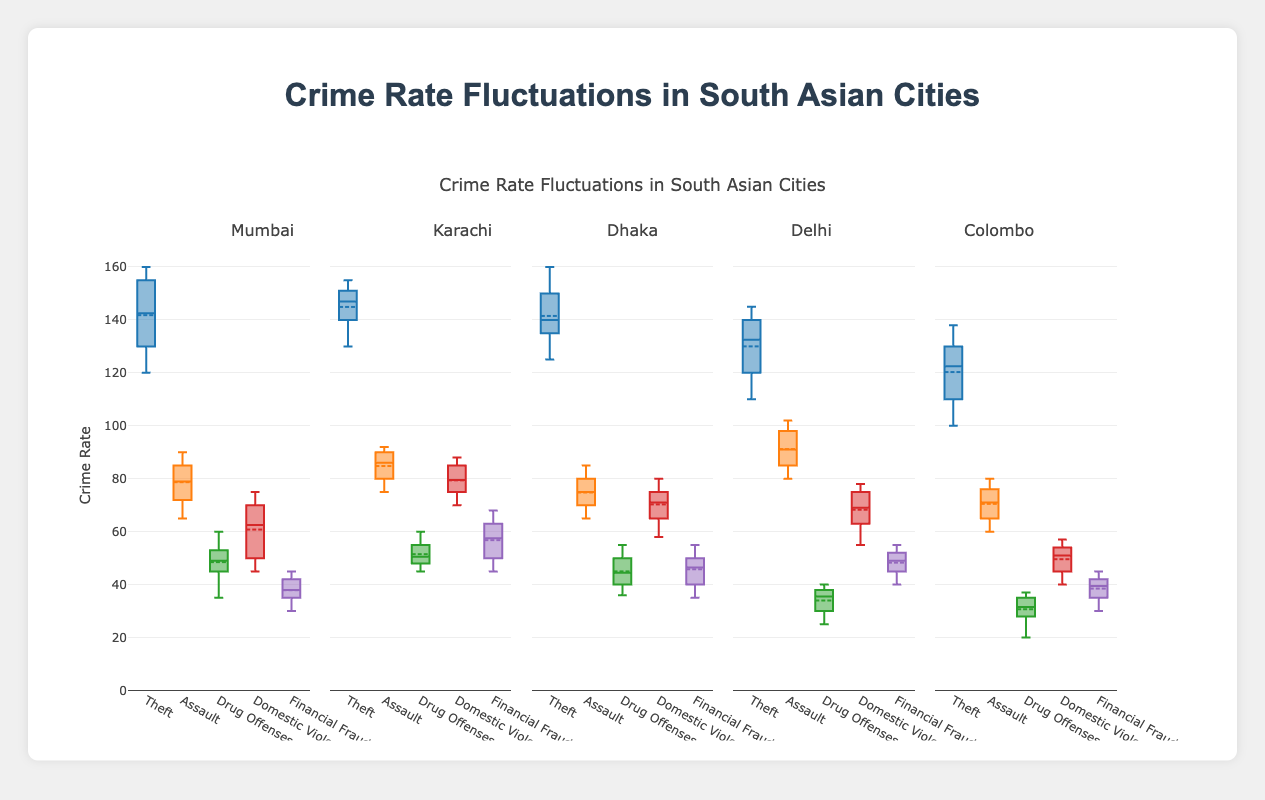What's the title of the figure? The title is displayed at the top of the chart which reads "Crime Rate Fluctuations in South Asian Cities."
Answer: Crime Rate Fluctuations in South Asian Cities Which district appears on the far right of the x-axis in the figure? The districts are listed in order from left to right along the x-axis, with Colombo being the last district on the far right.
Answer: Colombo What is the range of the y-axis in the figure? The y-axis shows the range of crime rates from 0 to 170, as indicated by the labels on the axis.
Answer: 0 to 170 Which district has the highest median value for "Domestic Violence"? By examining the median lines within the boxes for each district under "Domestic Violence," Karachi has the highest median line.
Answer: Karachi How many crime categories are plotted for each district? Each district has one box plot per crime category, and there are five categories: Theft, Assault, Drug Offenses, Domestic Violence, Financial Fraud.
Answer: 5 Which crime category in Dhaka has the lowest median value? Looking at the median lines within the boxes for Dhaka, "Drug Offenses" has the lowest median value.
Answer: Drug Offenses What is the IQR (Interquartile Range) for Assault in Delhi? The IQR is the difference between the third quartile (Q3) and the first quartile (Q1). For "Assault" in Delhi, Q3 is approximately 90, and Q1 is approximately 80. So IQR = 90 - 80 = 10.
Answer: 10 Which crime category in Mumbai has the widest range of data points? By examining the extent of the whiskers for each category in Mumbai, "Theft" shows the widest range of data points.
Answer: Theft Between Karachi and Colombo, which district has a higher mean value for "Drug Offenses"? The mean is shown with a dot inside the boxplot. Comparing "Drug Offenses" between Karachi and Colombo, Karachi has a higher mean value.
Answer: Karachi Which crime category shows the least variation in crime rates across all districts? The box plots that are most compact and have the smallest range of whiskers indicate the least variation. "Financial Fraud" shows the least variation across all districts.
Answer: Financial Fraud 